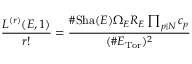<formula> <loc_0><loc_0><loc_500><loc_500>{ \frac { L ^ { ( r ) } ( E , 1 ) } { r ! } } = { \frac { \# S h a ( E ) \Omega _ { E } R _ { E } \prod _ { p | N } c _ { p } } { ( \# E _ { T o r } ) ^ { 2 } } }</formula> 